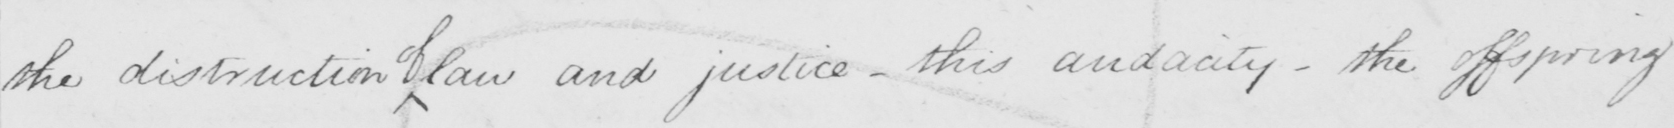What does this handwritten line say? the distruction law and justice  _  this audacity  _  the offspring 